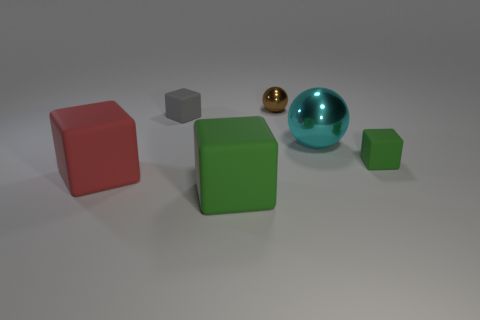How many objects are small brown matte cylinders or cyan metal balls behind the large red rubber thing?
Ensure brevity in your answer.  1. How many big red rubber cubes are behind the small rubber thing behind the green block that is behind the big red block?
Ensure brevity in your answer.  0. What number of tiny cyan cylinders are there?
Your answer should be compact. 0. Is the size of the ball behind the gray rubber cube the same as the small gray cube?
Your answer should be compact. Yes. What number of shiny things are either big brown cylinders or brown things?
Your answer should be compact. 1. There is a tiny object in front of the big cyan object; what number of green rubber objects are on the left side of it?
Offer a very short reply. 1. What shape is the thing that is on the right side of the gray cube and in front of the tiny green matte block?
Your response must be concise. Cube. There is a large thing to the right of the green block that is on the left side of the green block to the right of the brown metallic object; what is its material?
Your answer should be very brief. Metal. What is the large ball made of?
Keep it short and to the point. Metal. Does the cyan sphere have the same material as the green block behind the red matte object?
Provide a succinct answer. No. 